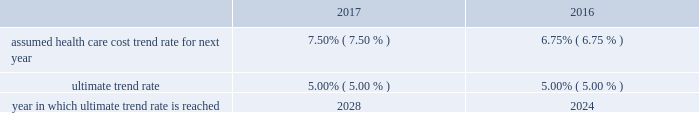Assumed health care cost trend rates for the u.s .
Retiree health care benefit plan as of december 31 are as follows: .
A one percentage point increase or decrease in health care cost trend rates over all future periods would have increased or decreased the accumulated postretirement benefit obligation for the u.s .
Retiree health care benefit plan as of december 31 , 2017 , by $ 1 million .
The service cost and interest cost components of 2017 plan expense would have increased or decreased by less than $ 1 million .
Deferred compensation arrangements we have a deferred compensation plan that allows u.s .
Employees whose base salary and management responsibility exceed a certain level to defer receipt of a portion of their cash compensation .
Payments under this plan are made based on the participant 2019s distribution election and plan balance .
Participants can earn a return on their deferred compensation based on notional investments in the same investment funds that are offered in our defined contribution plans .
As of december 31 , 2017 , our liability to participants of the deferred compensation plans was $ 255 million and is recorded in other long-term liabilities on our consolidated balance sheets .
This amount reflects the accumulated participant deferrals and earnings thereon as of that date .
As of december 31 , 2017 , we held $ 236 million in mutual funds related to these plans that are recorded in long-term investments on our consolidated balance sheets , and serve as an economic hedge against changes in fair values of our other deferred compensation liabilities .
We record changes in the fair value of the liability and the related investment in sg&a as discussed in note 8 .
11 .
Debt and lines of credit short-term borrowings we maintain a line of credit to support commercial paper borrowings , if any , and to provide additional liquidity through bank loans .
As of december 31 , 2017 , we had a variable-rate revolving credit facility from a consortium of investment-grade banks that allows us to borrow up to $ 2 billion until march 2022 .
The interest rate on borrowings under this credit facility , if drawn , is indexed to the applicable london interbank offered rate ( libor ) .
As of december 31 , 2017 , our credit facility was undrawn and we had no commercial paper outstanding .
Long-term debt we retired $ 250 million of maturing debt in march 2017 and another $ 375 million in june 2017 .
In may 2017 , we issued an aggregate principal amount of $ 600 million of fixed-rate , long-term debt .
The offering consisted of the reissuance of $ 300 million of 2.75% ( 2.75 % ) notes due in 2021 at a premium and the issuance of $ 300 million of 2.625% ( 2.625 % ) notes due in 2024 at a discount .
We incurred $ 3 million of issuance and other related costs .
The proceeds of the offerings were $ 605 million , net of the original issuance discount and premium , and were used for the repayment of maturing debt and general corporate purposes .
In november 2017 , we issued a principal amount of $ 500 million of fixed-rate , long-term debt due in 2027 .
We incurred $ 3 million of issuance and other related costs .
The proceeds of the offering were $ 494 million , net of the original issuance discount , and were used for general corporate purposes .
In may 2016 , we issued a principal amount of $ 500 million of fixed-rate , long-term debt due in 2022 .
We incurred $ 3 million of issuance and other related costs .
The proceeds of the offering were $ 499 million , net of the original issuance discount , and were used toward the repayment of a portion of $ 1.0 billion of maturing debt retired in may 2016 .
In may 2015 , we issued a principal amount of $ 500 million of fixed-rate , long-term debt due in 2020 .
We incurred $ 3 million of issuance and other related costs .
The proceeds of the offering were $ 498 million , net of the original issuance discount , and were used toward the repayment of a portion of the debt that matured in august 2015 .
We retired $ 250 million of maturing debt in april 2015 and another $ 750 million in august 2015 .
Texas instruments 2022 2017 form 10-k 51 .
By how many percentage points did the health care cost trend rate for next year increase in 2017? 
Computations: (7.50 - 6.75)
Answer: 0.75. Assumed health care cost trend rates for the u.s .
Retiree health care benefit plan as of december 31 are as follows: .
A one percentage point increase or decrease in health care cost trend rates over all future periods would have increased or decreased the accumulated postretirement benefit obligation for the u.s .
Retiree health care benefit plan as of december 31 , 2017 , by $ 1 million .
The service cost and interest cost components of 2017 plan expense would have increased or decreased by less than $ 1 million .
Deferred compensation arrangements we have a deferred compensation plan that allows u.s .
Employees whose base salary and management responsibility exceed a certain level to defer receipt of a portion of their cash compensation .
Payments under this plan are made based on the participant 2019s distribution election and plan balance .
Participants can earn a return on their deferred compensation based on notional investments in the same investment funds that are offered in our defined contribution plans .
As of december 31 , 2017 , our liability to participants of the deferred compensation plans was $ 255 million and is recorded in other long-term liabilities on our consolidated balance sheets .
This amount reflects the accumulated participant deferrals and earnings thereon as of that date .
As of december 31 , 2017 , we held $ 236 million in mutual funds related to these plans that are recorded in long-term investments on our consolidated balance sheets , and serve as an economic hedge against changes in fair values of our other deferred compensation liabilities .
We record changes in the fair value of the liability and the related investment in sg&a as discussed in note 8 .
11 .
Debt and lines of credit short-term borrowings we maintain a line of credit to support commercial paper borrowings , if any , and to provide additional liquidity through bank loans .
As of december 31 , 2017 , we had a variable-rate revolving credit facility from a consortium of investment-grade banks that allows us to borrow up to $ 2 billion until march 2022 .
The interest rate on borrowings under this credit facility , if drawn , is indexed to the applicable london interbank offered rate ( libor ) .
As of december 31 , 2017 , our credit facility was undrawn and we had no commercial paper outstanding .
Long-term debt we retired $ 250 million of maturing debt in march 2017 and another $ 375 million in june 2017 .
In may 2017 , we issued an aggregate principal amount of $ 600 million of fixed-rate , long-term debt .
The offering consisted of the reissuance of $ 300 million of 2.75% ( 2.75 % ) notes due in 2021 at a premium and the issuance of $ 300 million of 2.625% ( 2.625 % ) notes due in 2024 at a discount .
We incurred $ 3 million of issuance and other related costs .
The proceeds of the offerings were $ 605 million , net of the original issuance discount and premium , and were used for the repayment of maturing debt and general corporate purposes .
In november 2017 , we issued a principal amount of $ 500 million of fixed-rate , long-term debt due in 2027 .
We incurred $ 3 million of issuance and other related costs .
The proceeds of the offering were $ 494 million , net of the original issuance discount , and were used for general corporate purposes .
In may 2016 , we issued a principal amount of $ 500 million of fixed-rate , long-term debt due in 2022 .
We incurred $ 3 million of issuance and other related costs .
The proceeds of the offering were $ 499 million , net of the original issuance discount , and were used toward the repayment of a portion of $ 1.0 billion of maturing debt retired in may 2016 .
In may 2015 , we issued a principal amount of $ 500 million of fixed-rate , long-term debt due in 2020 .
We incurred $ 3 million of issuance and other related costs .
The proceeds of the offering were $ 498 million , net of the original issuance discount , and were used toward the repayment of a portion of the debt that matured in august 2015 .
We retired $ 250 million of maturing debt in april 2015 and another $ 750 million in august 2015 .
Texas instruments 2022 2017 form 10-k 51 .
What is the net value of liabilities and investments related to these plans that are reported in the balance sheet at the end of 2017? 
Computations: (236 - 255)
Answer: -19.0. 